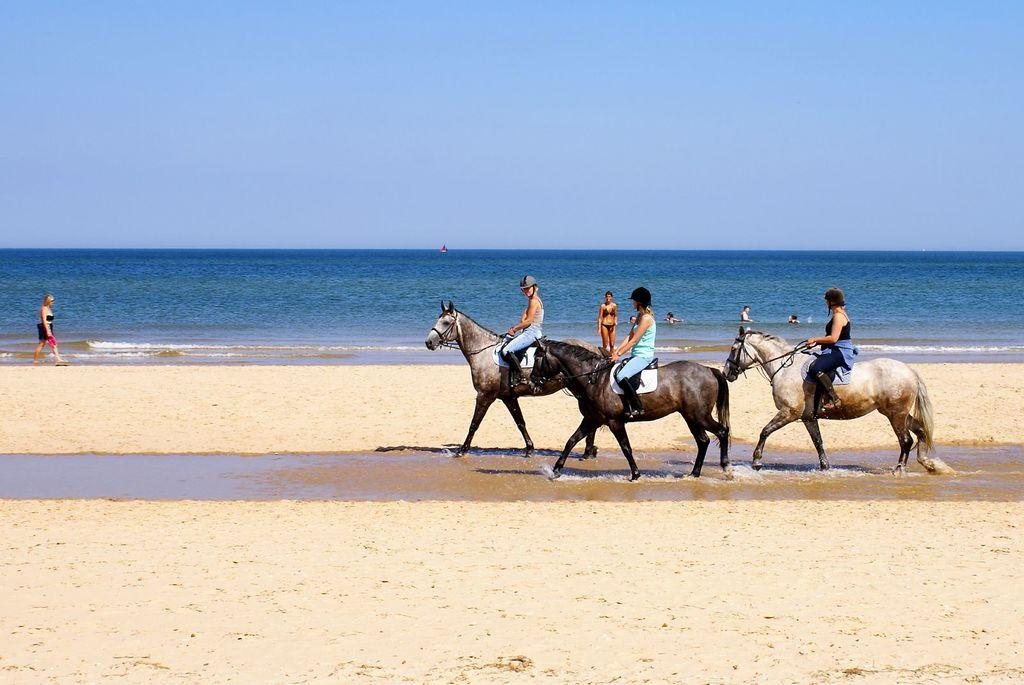What is happening in the image involving people? Some people are swimming in the ocean, and three persons are riding on a horse. What can be seen in the background of the image? The sky is visible in the image. What is the purpose of the women in the image? There is no mention of women in the image, so we cannot determine their purpose. 